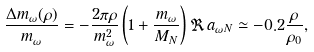Convert formula to latex. <formula><loc_0><loc_0><loc_500><loc_500>\frac { \Delta m _ { \omega } ( \rho ) } { m _ { \omega } } = - \frac { 2 \pi \rho } { m _ { \omega } ^ { 2 } } \left ( 1 + \frac { m _ { \omega } } { M _ { N } } \right ) \Re \, a _ { \omega N } \simeq - 0 . 2 \frac { \rho } { \rho _ { 0 } } ,</formula> 